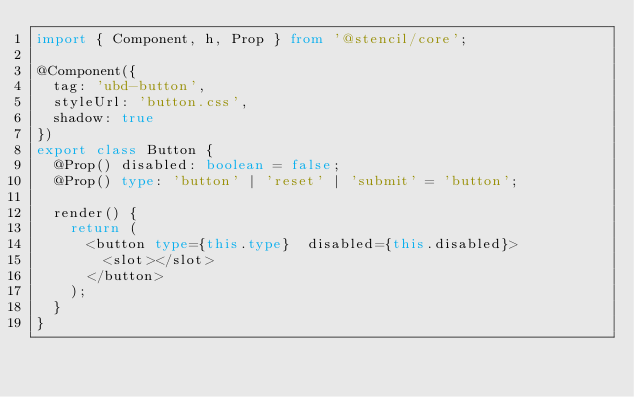<code> <loc_0><loc_0><loc_500><loc_500><_TypeScript_>import { Component, h, Prop } from '@stencil/core';

@Component({
  tag: 'ubd-button',
  styleUrl: 'button.css',
  shadow: true
})
export class Button {
  @Prop() disabled: boolean = false;
  @Prop() type: 'button' | 'reset' | 'submit' = 'button';

  render() {
    return (
      <button type={this.type}  disabled={this.disabled}>
        <slot></slot>
      </button>
    );
  }
}
</code> 